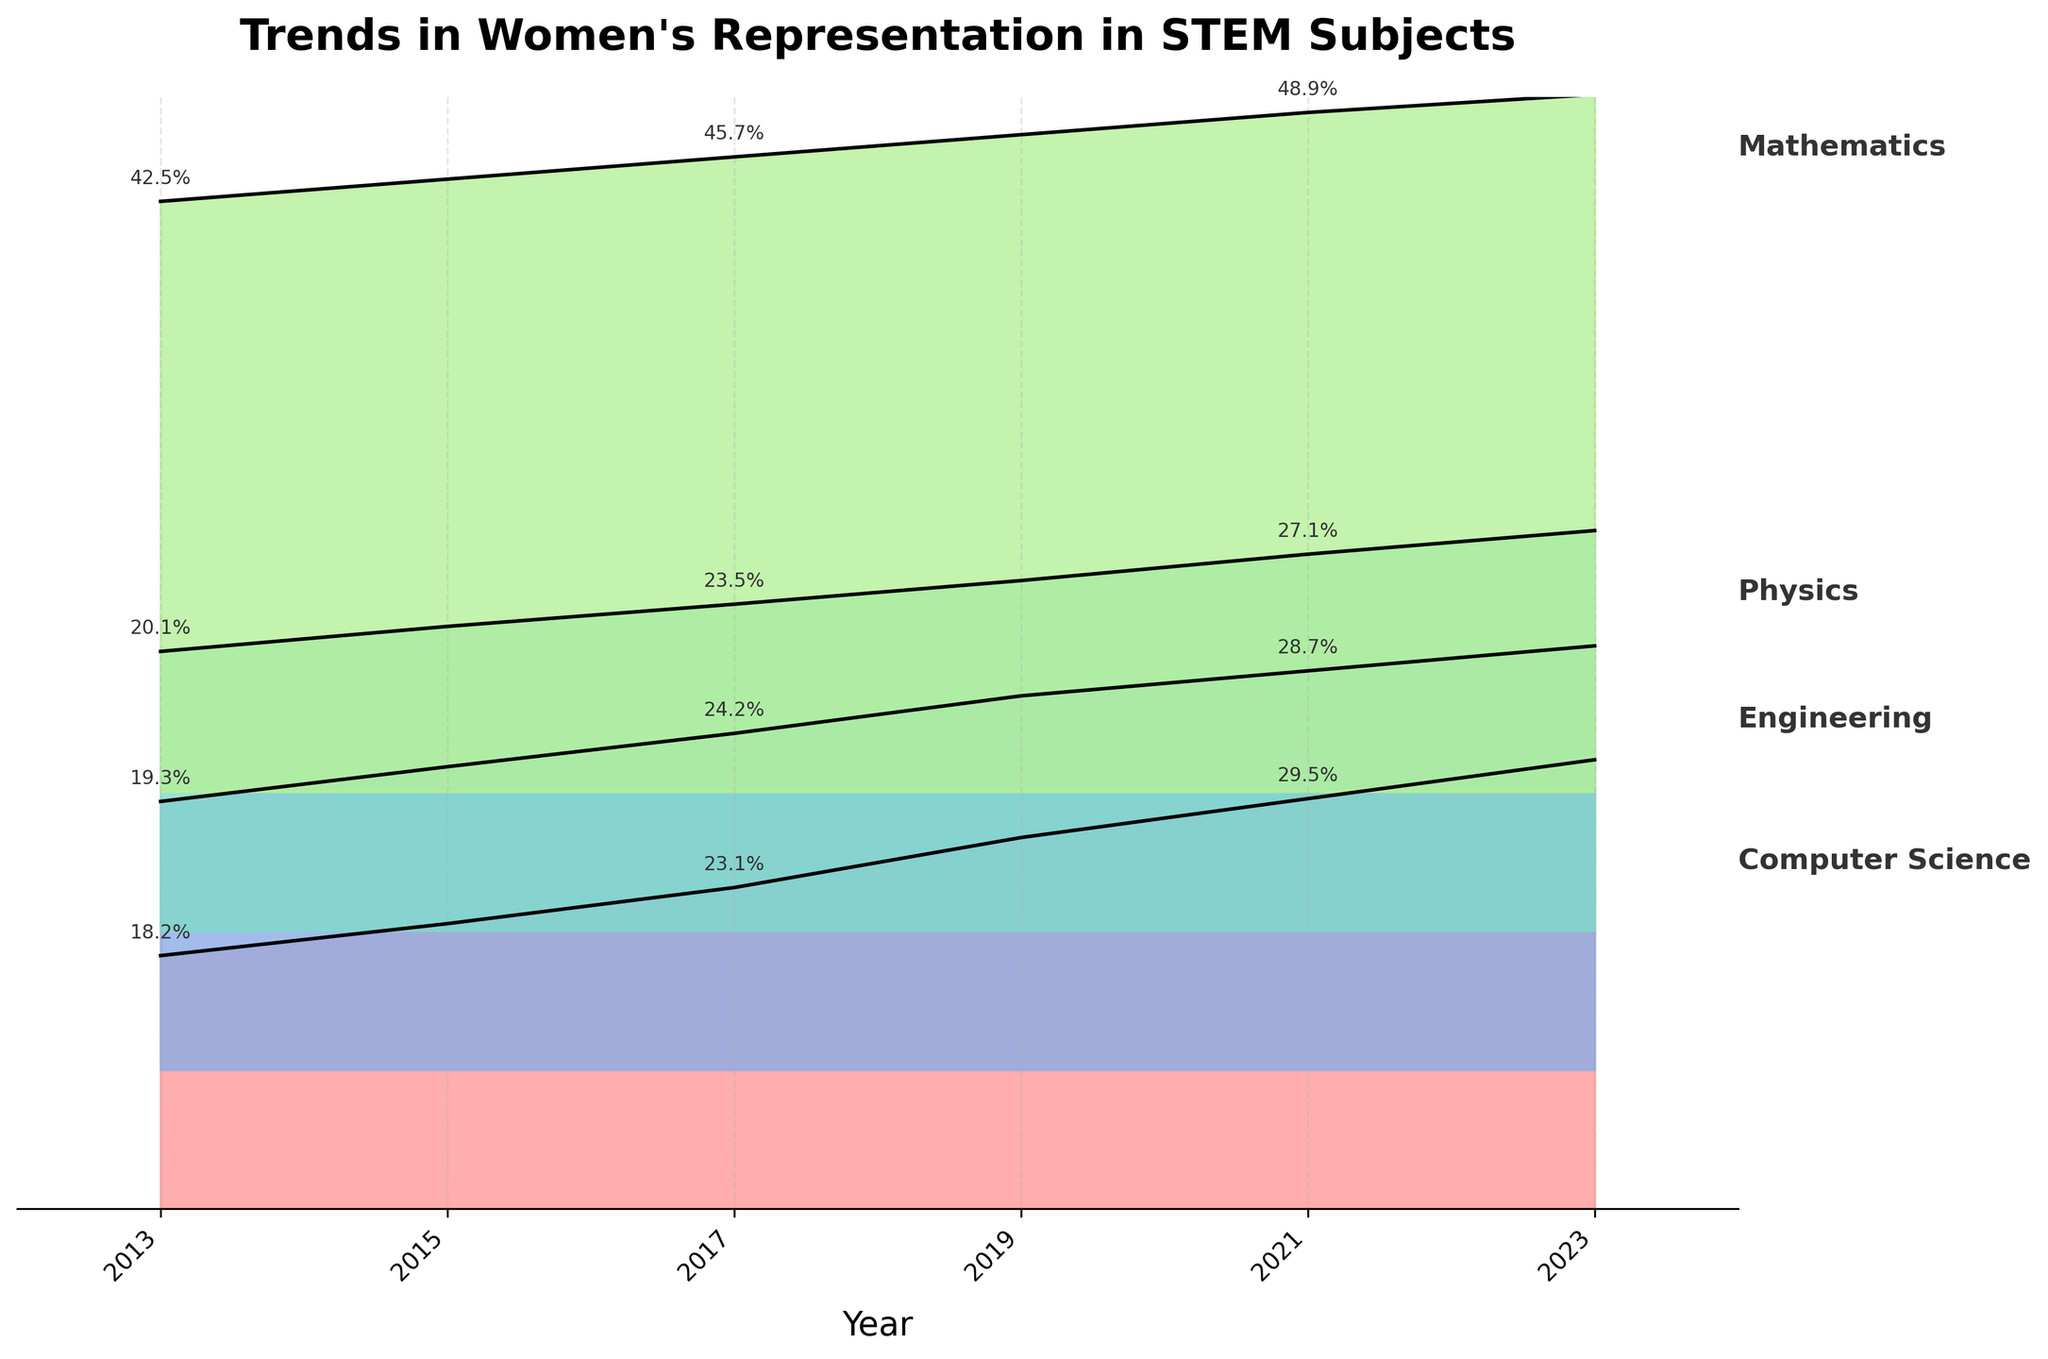What is the title of the plot? The title of the plot is generally located at the top and reflects the main theme of the figure. In this case, it reads "Trends in Women's Representation in STEM Subjects".
Answer: Trends in Women's Representation in STEM Subjects What does the x-axis represent? The x-axis typically represents a continuous variable and in this plot, it shows the "Year" ranging from 2013 to 2023.
Answer: Year Which subject had the highest percentage of women's representation in 2023? By examining the 2023 tick mark, we can see that Mathematics is clearly labeled with a percentage value for 2023, which is the highest among the subjects listed.
Answer: Mathematics How did the percentage of women's representation in Computer Science change from 2013 to 2023? By comparing the percentage values at the beginning (18.2% in 2013) and the end (32.3% in 2023) of the plot for Computer Science, we can observe the change.
Answer: Increased by 14.1% Which subject displayed the most consistent increase in women's representation over the years? To identify this, we observe the lines and the percentage values across the years for each subject. Mathematics has a steady and consistent upward trend.
Answer: Mathematics Between 2015 and 2017, which subject showed the biggest percentage increase in women's representation? By comparing the percentage values for each subject between 2015 and 2017, the difference for Computer Science is largest: from 20.5% to 23.1%, a 2.6% increase.
Answer: Computer Science What is the y-axis used for in this plot? The y-axis is used to indicate different subjects, with each subject's trend plotted with a specified offset to avoid overlapping, though it doesn't correspond to specific numerical values.
Answer: Subjects with offsets Which year had the highest average percentage of women’s representation across all STEM subjects? To calculate this, we average the percentages for all STEM subjects for each year and compare. The highest average is in 2023.
Answer: 2023 Compare the trends of women's representation in Engineering and Physics from 2013 to 2023. Which one increases more? By examining the start and end points for both subjects, Engineering increases from 19.3% to 30.5% (11.2%) whereas Physics increases from 20.1% to 28.8% (8.7%).
Answer: Engineering Which subject had the smallest increase in women's representation over the decade? By observing the difference between 2013 and 2023 values for each subject: Physics increased from 20.1% to 28.8%, the smallest among all subjects.
Answer: Physics 